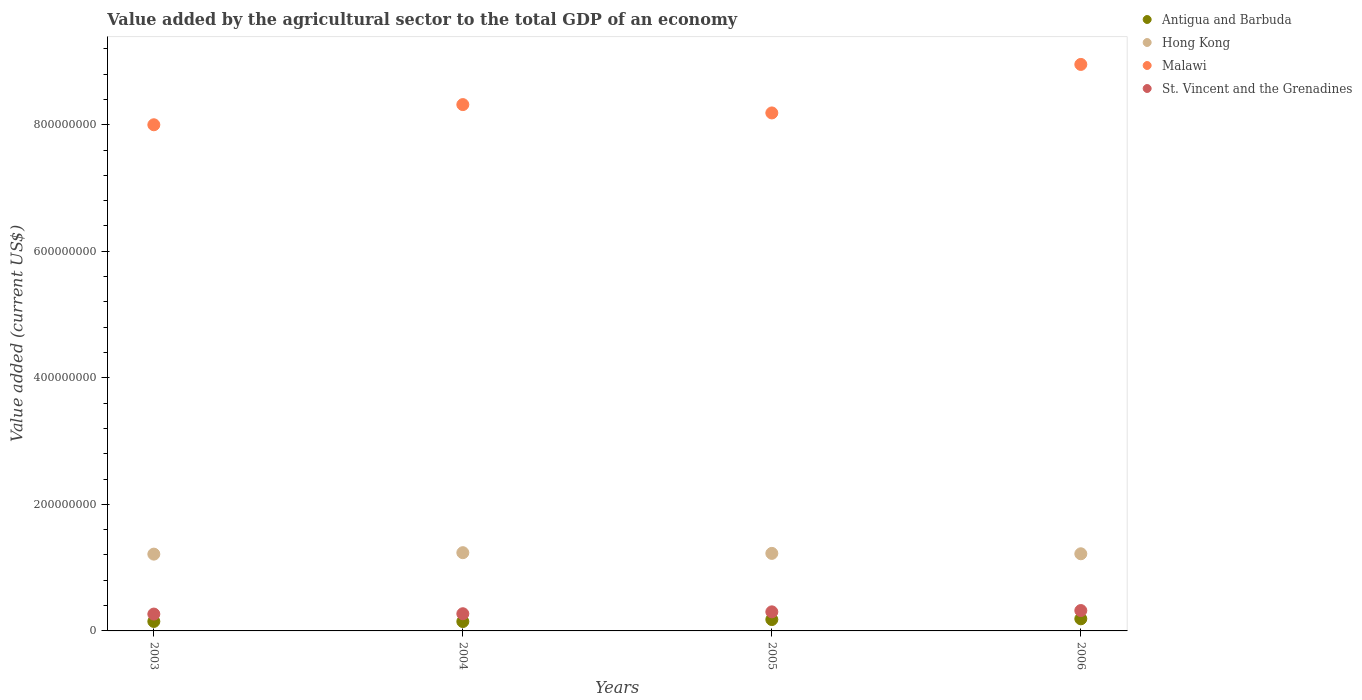Is the number of dotlines equal to the number of legend labels?
Your answer should be very brief. Yes. What is the value added by the agricultural sector to the total GDP in Malawi in 2005?
Offer a terse response. 8.19e+08. Across all years, what is the maximum value added by the agricultural sector to the total GDP in Malawi?
Your answer should be compact. 8.95e+08. Across all years, what is the minimum value added by the agricultural sector to the total GDP in St. Vincent and the Grenadines?
Your answer should be very brief. 2.66e+07. In which year was the value added by the agricultural sector to the total GDP in Hong Kong maximum?
Offer a terse response. 2004. In which year was the value added by the agricultural sector to the total GDP in Antigua and Barbuda minimum?
Your answer should be compact. 2004. What is the total value added by the agricultural sector to the total GDP in St. Vincent and the Grenadines in the graph?
Give a very brief answer. 1.16e+08. What is the difference between the value added by the agricultural sector to the total GDP in Malawi in 2005 and that in 2006?
Your answer should be very brief. -7.67e+07. What is the difference between the value added by the agricultural sector to the total GDP in St. Vincent and the Grenadines in 2004 and the value added by the agricultural sector to the total GDP in Hong Kong in 2005?
Your response must be concise. -9.54e+07. What is the average value added by the agricultural sector to the total GDP in Malawi per year?
Offer a terse response. 8.36e+08. In the year 2005, what is the difference between the value added by the agricultural sector to the total GDP in St. Vincent and the Grenadines and value added by the agricultural sector to the total GDP in Malawi?
Provide a succinct answer. -7.88e+08. In how many years, is the value added by the agricultural sector to the total GDP in Antigua and Barbuda greater than 120000000 US$?
Offer a very short reply. 0. What is the ratio of the value added by the agricultural sector to the total GDP in Malawi in 2004 to that in 2006?
Offer a terse response. 0.93. Is the value added by the agricultural sector to the total GDP in Hong Kong in 2005 less than that in 2006?
Give a very brief answer. No. What is the difference between the highest and the second highest value added by the agricultural sector to the total GDP in St. Vincent and the Grenadines?
Your answer should be compact. 2.04e+06. What is the difference between the highest and the lowest value added by the agricultural sector to the total GDP in Hong Kong?
Give a very brief answer. 2.29e+06. Is the sum of the value added by the agricultural sector to the total GDP in St. Vincent and the Grenadines in 2004 and 2005 greater than the maximum value added by the agricultural sector to the total GDP in Malawi across all years?
Your response must be concise. No. How many dotlines are there?
Provide a short and direct response. 4. Are the values on the major ticks of Y-axis written in scientific E-notation?
Offer a terse response. No. Does the graph contain grids?
Your answer should be very brief. No. How many legend labels are there?
Your answer should be very brief. 4. What is the title of the graph?
Make the answer very short. Value added by the agricultural sector to the total GDP of an economy. What is the label or title of the Y-axis?
Provide a short and direct response. Value added (current US$). What is the Value added (current US$) of Antigua and Barbuda in 2003?
Give a very brief answer. 1.50e+07. What is the Value added (current US$) of Hong Kong in 2003?
Provide a short and direct response. 1.21e+08. What is the Value added (current US$) in Malawi in 2003?
Give a very brief answer. 8.00e+08. What is the Value added (current US$) of St. Vincent and the Grenadines in 2003?
Offer a very short reply. 2.66e+07. What is the Value added (current US$) in Antigua and Barbuda in 2004?
Your answer should be compact. 1.48e+07. What is the Value added (current US$) of Hong Kong in 2004?
Your response must be concise. 1.24e+08. What is the Value added (current US$) in Malawi in 2004?
Make the answer very short. 8.32e+08. What is the Value added (current US$) in St. Vincent and the Grenadines in 2004?
Make the answer very short. 2.72e+07. What is the Value added (current US$) of Antigua and Barbuda in 2005?
Provide a succinct answer. 1.80e+07. What is the Value added (current US$) in Hong Kong in 2005?
Make the answer very short. 1.23e+08. What is the Value added (current US$) of Malawi in 2005?
Your answer should be compact. 8.19e+08. What is the Value added (current US$) in St. Vincent and the Grenadines in 2005?
Offer a very short reply. 3.01e+07. What is the Value added (current US$) of Antigua and Barbuda in 2006?
Your answer should be compact. 1.91e+07. What is the Value added (current US$) in Hong Kong in 2006?
Provide a short and direct response. 1.22e+08. What is the Value added (current US$) in Malawi in 2006?
Ensure brevity in your answer.  8.95e+08. What is the Value added (current US$) of St. Vincent and the Grenadines in 2006?
Keep it short and to the point. 3.22e+07. Across all years, what is the maximum Value added (current US$) of Antigua and Barbuda?
Make the answer very short. 1.91e+07. Across all years, what is the maximum Value added (current US$) of Hong Kong?
Provide a succinct answer. 1.24e+08. Across all years, what is the maximum Value added (current US$) in Malawi?
Your answer should be very brief. 8.95e+08. Across all years, what is the maximum Value added (current US$) in St. Vincent and the Grenadines?
Provide a succinct answer. 3.22e+07. Across all years, what is the minimum Value added (current US$) of Antigua and Barbuda?
Your response must be concise. 1.48e+07. Across all years, what is the minimum Value added (current US$) in Hong Kong?
Keep it short and to the point. 1.21e+08. Across all years, what is the minimum Value added (current US$) of Malawi?
Keep it short and to the point. 8.00e+08. Across all years, what is the minimum Value added (current US$) in St. Vincent and the Grenadines?
Provide a succinct answer. 2.66e+07. What is the total Value added (current US$) in Antigua and Barbuda in the graph?
Keep it short and to the point. 6.69e+07. What is the total Value added (current US$) of Hong Kong in the graph?
Ensure brevity in your answer.  4.89e+08. What is the total Value added (current US$) of Malawi in the graph?
Your answer should be compact. 3.35e+09. What is the total Value added (current US$) in St. Vincent and the Grenadines in the graph?
Your response must be concise. 1.16e+08. What is the difference between the Value added (current US$) in Antigua and Barbuda in 2003 and that in 2004?
Your response must be concise. 1.65e+05. What is the difference between the Value added (current US$) of Hong Kong in 2003 and that in 2004?
Make the answer very short. -2.29e+06. What is the difference between the Value added (current US$) of Malawi in 2003 and that in 2004?
Give a very brief answer. -3.19e+07. What is the difference between the Value added (current US$) in St. Vincent and the Grenadines in 2003 and that in 2004?
Give a very brief answer. -5.23e+05. What is the difference between the Value added (current US$) of Antigua and Barbuda in 2003 and that in 2005?
Your answer should be compact. -3.00e+06. What is the difference between the Value added (current US$) in Hong Kong in 2003 and that in 2005?
Ensure brevity in your answer.  -1.18e+06. What is the difference between the Value added (current US$) of Malawi in 2003 and that in 2005?
Provide a succinct answer. -1.87e+07. What is the difference between the Value added (current US$) in St. Vincent and the Grenadines in 2003 and that in 2005?
Give a very brief answer. -3.52e+06. What is the difference between the Value added (current US$) of Antigua and Barbuda in 2003 and that in 2006?
Offer a terse response. -4.16e+06. What is the difference between the Value added (current US$) in Hong Kong in 2003 and that in 2006?
Keep it short and to the point. -5.54e+05. What is the difference between the Value added (current US$) in Malawi in 2003 and that in 2006?
Your answer should be compact. -9.54e+07. What is the difference between the Value added (current US$) in St. Vincent and the Grenadines in 2003 and that in 2006?
Offer a terse response. -5.56e+06. What is the difference between the Value added (current US$) of Antigua and Barbuda in 2004 and that in 2005?
Provide a short and direct response. -3.16e+06. What is the difference between the Value added (current US$) in Hong Kong in 2004 and that in 2005?
Make the answer very short. 1.12e+06. What is the difference between the Value added (current US$) of Malawi in 2004 and that in 2005?
Your answer should be very brief. 1.32e+07. What is the difference between the Value added (current US$) in St. Vincent and the Grenadines in 2004 and that in 2005?
Your response must be concise. -3.00e+06. What is the difference between the Value added (current US$) in Antigua and Barbuda in 2004 and that in 2006?
Offer a terse response. -4.32e+06. What is the difference between the Value added (current US$) in Hong Kong in 2004 and that in 2006?
Provide a succinct answer. 1.74e+06. What is the difference between the Value added (current US$) in Malawi in 2004 and that in 2006?
Give a very brief answer. -6.35e+07. What is the difference between the Value added (current US$) in St. Vincent and the Grenadines in 2004 and that in 2006?
Ensure brevity in your answer.  -5.04e+06. What is the difference between the Value added (current US$) in Antigua and Barbuda in 2005 and that in 2006?
Offer a terse response. -1.16e+06. What is the difference between the Value added (current US$) of Hong Kong in 2005 and that in 2006?
Offer a terse response. 6.23e+05. What is the difference between the Value added (current US$) in Malawi in 2005 and that in 2006?
Provide a short and direct response. -7.67e+07. What is the difference between the Value added (current US$) in St. Vincent and the Grenadines in 2005 and that in 2006?
Your response must be concise. -2.04e+06. What is the difference between the Value added (current US$) in Antigua and Barbuda in 2003 and the Value added (current US$) in Hong Kong in 2004?
Provide a succinct answer. -1.09e+08. What is the difference between the Value added (current US$) in Antigua and Barbuda in 2003 and the Value added (current US$) in Malawi in 2004?
Offer a terse response. -8.17e+08. What is the difference between the Value added (current US$) in Antigua and Barbuda in 2003 and the Value added (current US$) in St. Vincent and the Grenadines in 2004?
Provide a succinct answer. -1.22e+07. What is the difference between the Value added (current US$) in Hong Kong in 2003 and the Value added (current US$) in Malawi in 2004?
Ensure brevity in your answer.  -7.10e+08. What is the difference between the Value added (current US$) of Hong Kong in 2003 and the Value added (current US$) of St. Vincent and the Grenadines in 2004?
Provide a short and direct response. 9.42e+07. What is the difference between the Value added (current US$) in Malawi in 2003 and the Value added (current US$) in St. Vincent and the Grenadines in 2004?
Your answer should be compact. 7.73e+08. What is the difference between the Value added (current US$) in Antigua and Barbuda in 2003 and the Value added (current US$) in Hong Kong in 2005?
Keep it short and to the point. -1.08e+08. What is the difference between the Value added (current US$) of Antigua and Barbuda in 2003 and the Value added (current US$) of Malawi in 2005?
Provide a short and direct response. -8.04e+08. What is the difference between the Value added (current US$) in Antigua and Barbuda in 2003 and the Value added (current US$) in St. Vincent and the Grenadines in 2005?
Offer a terse response. -1.52e+07. What is the difference between the Value added (current US$) of Hong Kong in 2003 and the Value added (current US$) of Malawi in 2005?
Make the answer very short. -6.97e+08. What is the difference between the Value added (current US$) in Hong Kong in 2003 and the Value added (current US$) in St. Vincent and the Grenadines in 2005?
Your response must be concise. 9.12e+07. What is the difference between the Value added (current US$) in Malawi in 2003 and the Value added (current US$) in St. Vincent and the Grenadines in 2005?
Your response must be concise. 7.70e+08. What is the difference between the Value added (current US$) in Antigua and Barbuda in 2003 and the Value added (current US$) in Hong Kong in 2006?
Your answer should be compact. -1.07e+08. What is the difference between the Value added (current US$) of Antigua and Barbuda in 2003 and the Value added (current US$) of Malawi in 2006?
Provide a succinct answer. -8.80e+08. What is the difference between the Value added (current US$) in Antigua and Barbuda in 2003 and the Value added (current US$) in St. Vincent and the Grenadines in 2006?
Your answer should be very brief. -1.72e+07. What is the difference between the Value added (current US$) of Hong Kong in 2003 and the Value added (current US$) of Malawi in 2006?
Keep it short and to the point. -7.74e+08. What is the difference between the Value added (current US$) in Hong Kong in 2003 and the Value added (current US$) in St. Vincent and the Grenadines in 2006?
Your response must be concise. 8.92e+07. What is the difference between the Value added (current US$) in Malawi in 2003 and the Value added (current US$) in St. Vincent and the Grenadines in 2006?
Offer a terse response. 7.68e+08. What is the difference between the Value added (current US$) in Antigua and Barbuda in 2004 and the Value added (current US$) in Hong Kong in 2005?
Offer a terse response. -1.08e+08. What is the difference between the Value added (current US$) in Antigua and Barbuda in 2004 and the Value added (current US$) in Malawi in 2005?
Make the answer very short. -8.04e+08. What is the difference between the Value added (current US$) in Antigua and Barbuda in 2004 and the Value added (current US$) in St. Vincent and the Grenadines in 2005?
Make the answer very short. -1.53e+07. What is the difference between the Value added (current US$) in Hong Kong in 2004 and the Value added (current US$) in Malawi in 2005?
Offer a terse response. -6.95e+08. What is the difference between the Value added (current US$) of Hong Kong in 2004 and the Value added (current US$) of St. Vincent and the Grenadines in 2005?
Your response must be concise. 9.35e+07. What is the difference between the Value added (current US$) in Malawi in 2004 and the Value added (current US$) in St. Vincent and the Grenadines in 2005?
Give a very brief answer. 8.02e+08. What is the difference between the Value added (current US$) of Antigua and Barbuda in 2004 and the Value added (current US$) of Hong Kong in 2006?
Ensure brevity in your answer.  -1.07e+08. What is the difference between the Value added (current US$) in Antigua and Barbuda in 2004 and the Value added (current US$) in Malawi in 2006?
Offer a very short reply. -8.80e+08. What is the difference between the Value added (current US$) of Antigua and Barbuda in 2004 and the Value added (current US$) of St. Vincent and the Grenadines in 2006?
Make the answer very short. -1.74e+07. What is the difference between the Value added (current US$) in Hong Kong in 2004 and the Value added (current US$) in Malawi in 2006?
Offer a terse response. -7.72e+08. What is the difference between the Value added (current US$) of Hong Kong in 2004 and the Value added (current US$) of St. Vincent and the Grenadines in 2006?
Your answer should be compact. 9.15e+07. What is the difference between the Value added (current US$) of Malawi in 2004 and the Value added (current US$) of St. Vincent and the Grenadines in 2006?
Give a very brief answer. 8.00e+08. What is the difference between the Value added (current US$) in Antigua and Barbuda in 2005 and the Value added (current US$) in Hong Kong in 2006?
Provide a succinct answer. -1.04e+08. What is the difference between the Value added (current US$) in Antigua and Barbuda in 2005 and the Value added (current US$) in Malawi in 2006?
Ensure brevity in your answer.  -8.77e+08. What is the difference between the Value added (current US$) in Antigua and Barbuda in 2005 and the Value added (current US$) in St. Vincent and the Grenadines in 2006?
Offer a terse response. -1.42e+07. What is the difference between the Value added (current US$) of Hong Kong in 2005 and the Value added (current US$) of Malawi in 2006?
Your answer should be compact. -7.73e+08. What is the difference between the Value added (current US$) in Hong Kong in 2005 and the Value added (current US$) in St. Vincent and the Grenadines in 2006?
Offer a terse response. 9.03e+07. What is the difference between the Value added (current US$) in Malawi in 2005 and the Value added (current US$) in St. Vincent and the Grenadines in 2006?
Your answer should be compact. 7.86e+08. What is the average Value added (current US$) in Antigua and Barbuda per year?
Provide a succinct answer. 1.67e+07. What is the average Value added (current US$) of Hong Kong per year?
Provide a short and direct response. 1.22e+08. What is the average Value added (current US$) of Malawi per year?
Your response must be concise. 8.36e+08. What is the average Value added (current US$) of St. Vincent and the Grenadines per year?
Your answer should be compact. 2.90e+07. In the year 2003, what is the difference between the Value added (current US$) in Antigua and Barbuda and Value added (current US$) in Hong Kong?
Provide a short and direct response. -1.06e+08. In the year 2003, what is the difference between the Value added (current US$) of Antigua and Barbuda and Value added (current US$) of Malawi?
Your response must be concise. -7.85e+08. In the year 2003, what is the difference between the Value added (current US$) of Antigua and Barbuda and Value added (current US$) of St. Vincent and the Grenadines?
Provide a short and direct response. -1.17e+07. In the year 2003, what is the difference between the Value added (current US$) of Hong Kong and Value added (current US$) of Malawi?
Your response must be concise. -6.79e+08. In the year 2003, what is the difference between the Value added (current US$) of Hong Kong and Value added (current US$) of St. Vincent and the Grenadines?
Your answer should be very brief. 9.47e+07. In the year 2003, what is the difference between the Value added (current US$) in Malawi and Value added (current US$) in St. Vincent and the Grenadines?
Offer a terse response. 7.73e+08. In the year 2004, what is the difference between the Value added (current US$) in Antigua and Barbuda and Value added (current US$) in Hong Kong?
Provide a succinct answer. -1.09e+08. In the year 2004, what is the difference between the Value added (current US$) of Antigua and Barbuda and Value added (current US$) of Malawi?
Offer a terse response. -8.17e+08. In the year 2004, what is the difference between the Value added (current US$) in Antigua and Barbuda and Value added (current US$) in St. Vincent and the Grenadines?
Your answer should be compact. -1.23e+07. In the year 2004, what is the difference between the Value added (current US$) in Hong Kong and Value added (current US$) in Malawi?
Provide a succinct answer. -7.08e+08. In the year 2004, what is the difference between the Value added (current US$) in Hong Kong and Value added (current US$) in St. Vincent and the Grenadines?
Provide a short and direct response. 9.65e+07. In the year 2004, what is the difference between the Value added (current US$) in Malawi and Value added (current US$) in St. Vincent and the Grenadines?
Your response must be concise. 8.05e+08. In the year 2005, what is the difference between the Value added (current US$) of Antigua and Barbuda and Value added (current US$) of Hong Kong?
Provide a succinct answer. -1.05e+08. In the year 2005, what is the difference between the Value added (current US$) of Antigua and Barbuda and Value added (current US$) of Malawi?
Ensure brevity in your answer.  -8.01e+08. In the year 2005, what is the difference between the Value added (current US$) of Antigua and Barbuda and Value added (current US$) of St. Vincent and the Grenadines?
Give a very brief answer. -1.22e+07. In the year 2005, what is the difference between the Value added (current US$) of Hong Kong and Value added (current US$) of Malawi?
Your answer should be compact. -6.96e+08. In the year 2005, what is the difference between the Value added (current US$) of Hong Kong and Value added (current US$) of St. Vincent and the Grenadines?
Offer a terse response. 9.24e+07. In the year 2005, what is the difference between the Value added (current US$) in Malawi and Value added (current US$) in St. Vincent and the Grenadines?
Offer a terse response. 7.88e+08. In the year 2006, what is the difference between the Value added (current US$) of Antigua and Barbuda and Value added (current US$) of Hong Kong?
Give a very brief answer. -1.03e+08. In the year 2006, what is the difference between the Value added (current US$) in Antigua and Barbuda and Value added (current US$) in Malawi?
Your answer should be compact. -8.76e+08. In the year 2006, what is the difference between the Value added (current US$) of Antigua and Barbuda and Value added (current US$) of St. Vincent and the Grenadines?
Offer a very short reply. -1.31e+07. In the year 2006, what is the difference between the Value added (current US$) in Hong Kong and Value added (current US$) in Malawi?
Offer a very short reply. -7.73e+08. In the year 2006, what is the difference between the Value added (current US$) in Hong Kong and Value added (current US$) in St. Vincent and the Grenadines?
Offer a terse response. 8.97e+07. In the year 2006, what is the difference between the Value added (current US$) in Malawi and Value added (current US$) in St. Vincent and the Grenadines?
Make the answer very short. 8.63e+08. What is the ratio of the Value added (current US$) of Antigua and Barbuda in 2003 to that in 2004?
Provide a succinct answer. 1.01. What is the ratio of the Value added (current US$) of Hong Kong in 2003 to that in 2004?
Keep it short and to the point. 0.98. What is the ratio of the Value added (current US$) in Malawi in 2003 to that in 2004?
Ensure brevity in your answer.  0.96. What is the ratio of the Value added (current US$) in St. Vincent and the Grenadines in 2003 to that in 2004?
Provide a succinct answer. 0.98. What is the ratio of the Value added (current US$) in Antigua and Barbuda in 2003 to that in 2005?
Give a very brief answer. 0.83. What is the ratio of the Value added (current US$) in Hong Kong in 2003 to that in 2005?
Ensure brevity in your answer.  0.99. What is the ratio of the Value added (current US$) of Malawi in 2003 to that in 2005?
Offer a terse response. 0.98. What is the ratio of the Value added (current US$) of St. Vincent and the Grenadines in 2003 to that in 2005?
Offer a terse response. 0.88. What is the ratio of the Value added (current US$) in Antigua and Barbuda in 2003 to that in 2006?
Provide a short and direct response. 0.78. What is the ratio of the Value added (current US$) of Hong Kong in 2003 to that in 2006?
Keep it short and to the point. 1. What is the ratio of the Value added (current US$) in Malawi in 2003 to that in 2006?
Provide a short and direct response. 0.89. What is the ratio of the Value added (current US$) of St. Vincent and the Grenadines in 2003 to that in 2006?
Offer a terse response. 0.83. What is the ratio of the Value added (current US$) of Antigua and Barbuda in 2004 to that in 2005?
Provide a short and direct response. 0.82. What is the ratio of the Value added (current US$) of Hong Kong in 2004 to that in 2005?
Keep it short and to the point. 1.01. What is the ratio of the Value added (current US$) of Malawi in 2004 to that in 2005?
Give a very brief answer. 1.02. What is the ratio of the Value added (current US$) of St. Vincent and the Grenadines in 2004 to that in 2005?
Offer a terse response. 0.9. What is the ratio of the Value added (current US$) of Antigua and Barbuda in 2004 to that in 2006?
Keep it short and to the point. 0.77. What is the ratio of the Value added (current US$) of Hong Kong in 2004 to that in 2006?
Your answer should be very brief. 1.01. What is the ratio of the Value added (current US$) in Malawi in 2004 to that in 2006?
Give a very brief answer. 0.93. What is the ratio of the Value added (current US$) in St. Vincent and the Grenadines in 2004 to that in 2006?
Your answer should be very brief. 0.84. What is the ratio of the Value added (current US$) in Antigua and Barbuda in 2005 to that in 2006?
Your response must be concise. 0.94. What is the ratio of the Value added (current US$) in Malawi in 2005 to that in 2006?
Your response must be concise. 0.91. What is the ratio of the Value added (current US$) in St. Vincent and the Grenadines in 2005 to that in 2006?
Your answer should be compact. 0.94. What is the difference between the highest and the second highest Value added (current US$) in Antigua and Barbuda?
Ensure brevity in your answer.  1.16e+06. What is the difference between the highest and the second highest Value added (current US$) in Hong Kong?
Keep it short and to the point. 1.12e+06. What is the difference between the highest and the second highest Value added (current US$) of Malawi?
Your response must be concise. 6.35e+07. What is the difference between the highest and the second highest Value added (current US$) of St. Vincent and the Grenadines?
Ensure brevity in your answer.  2.04e+06. What is the difference between the highest and the lowest Value added (current US$) of Antigua and Barbuda?
Provide a succinct answer. 4.32e+06. What is the difference between the highest and the lowest Value added (current US$) in Hong Kong?
Offer a very short reply. 2.29e+06. What is the difference between the highest and the lowest Value added (current US$) in Malawi?
Give a very brief answer. 9.54e+07. What is the difference between the highest and the lowest Value added (current US$) of St. Vincent and the Grenadines?
Offer a very short reply. 5.56e+06. 